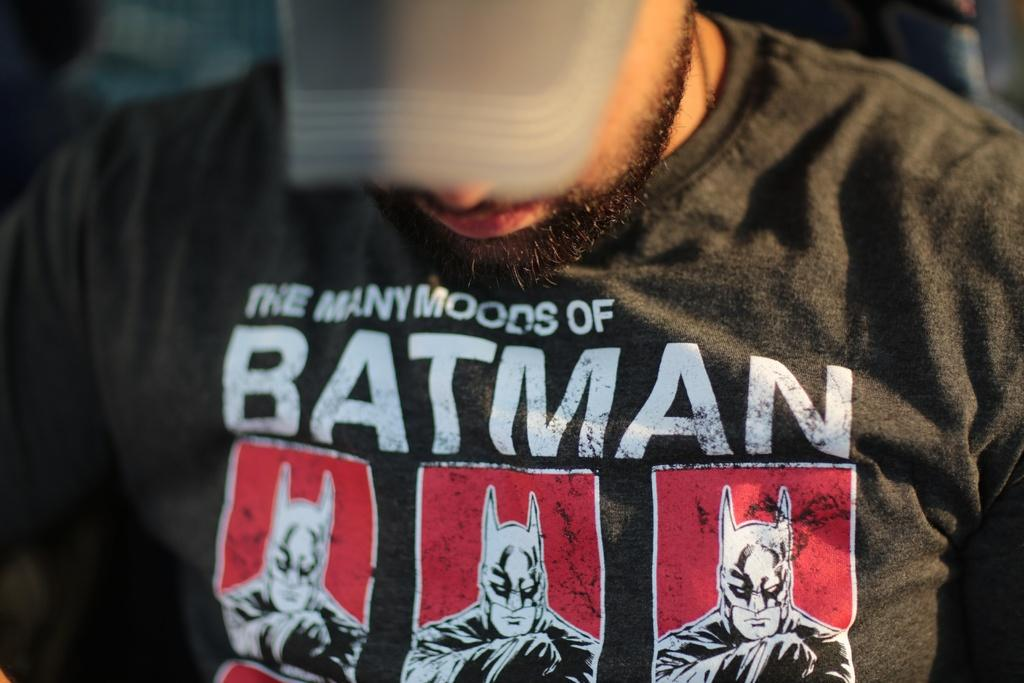Who is present in the image? There is a man in the image. What is the man wearing on his upper body? The man is wearing a t-shirt. What is the man wearing on his head? The man is wearing a cap. What design is featured on the man's t-shirt? There are Batman pictures on his t-shirt. How does the man control the drain in the image? There is no drain present in the image, and the man is not shown controlling anything related to a drain. 